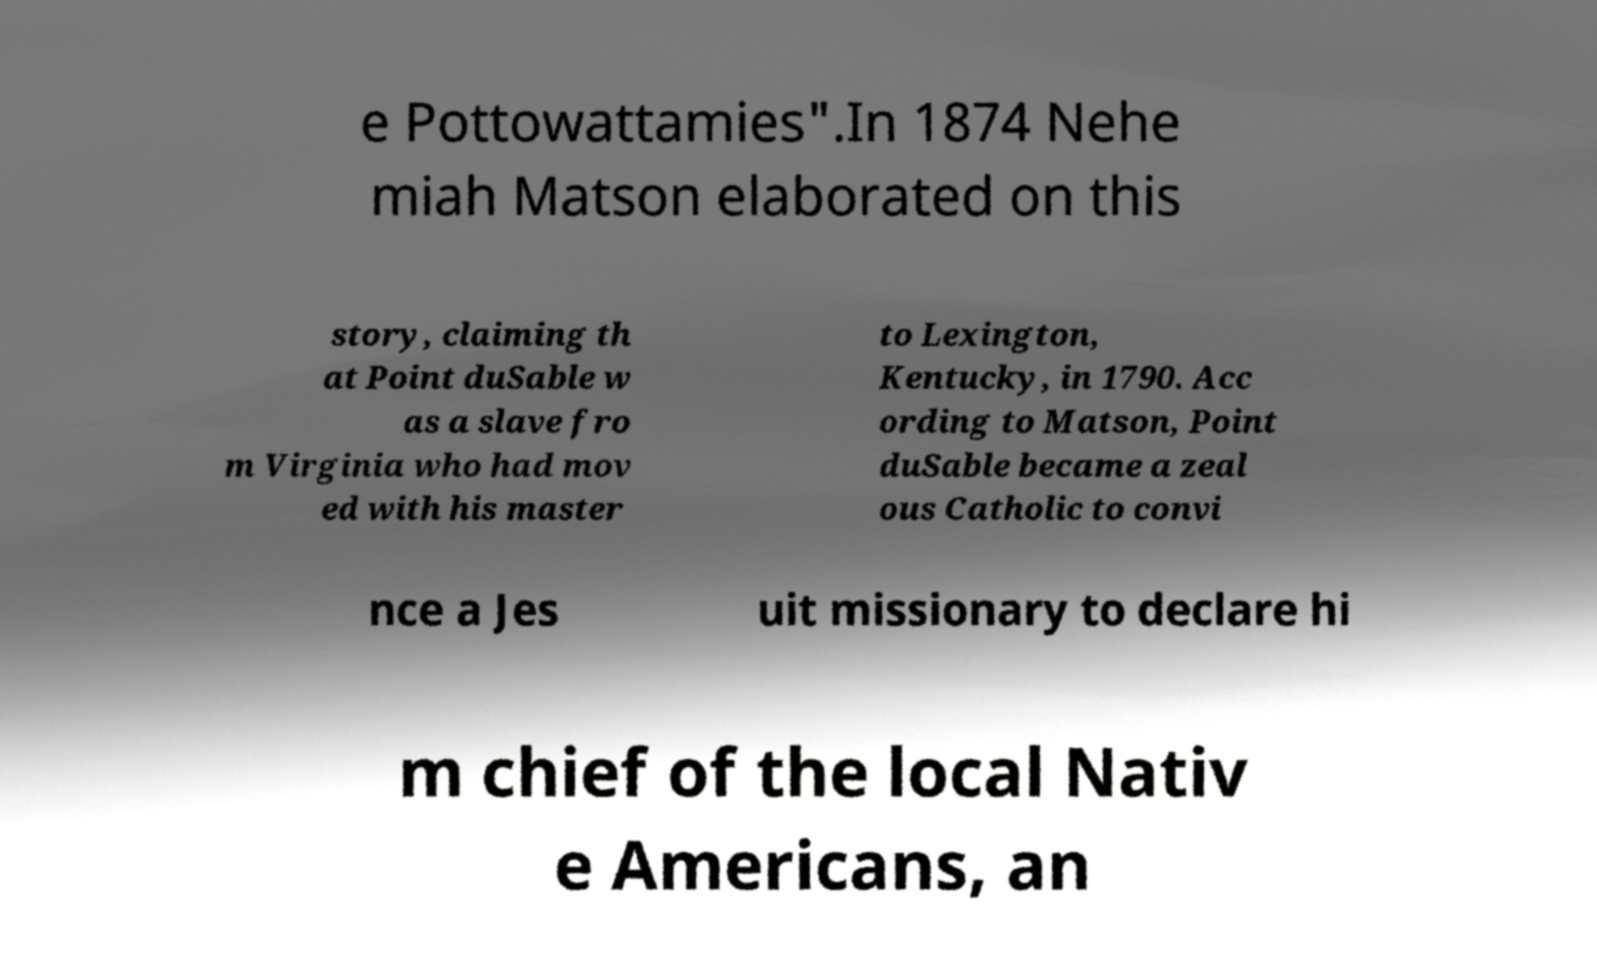Could you assist in decoding the text presented in this image and type it out clearly? e Pottowattamies".In 1874 Nehe miah Matson elaborated on this story, claiming th at Point duSable w as a slave fro m Virginia who had mov ed with his master to Lexington, Kentucky, in 1790. Acc ording to Matson, Point duSable became a zeal ous Catholic to convi nce a Jes uit missionary to declare hi m chief of the local Nativ e Americans, an 